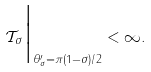Convert formula to latex. <formula><loc_0><loc_0><loc_500><loc_500>\mathcal { T } _ { \sigma } \Big | _ { \theta _ { \sigma } ^ { \prime } = \pi ( 1 - \sigma ) / 2 } < \infty .</formula> 